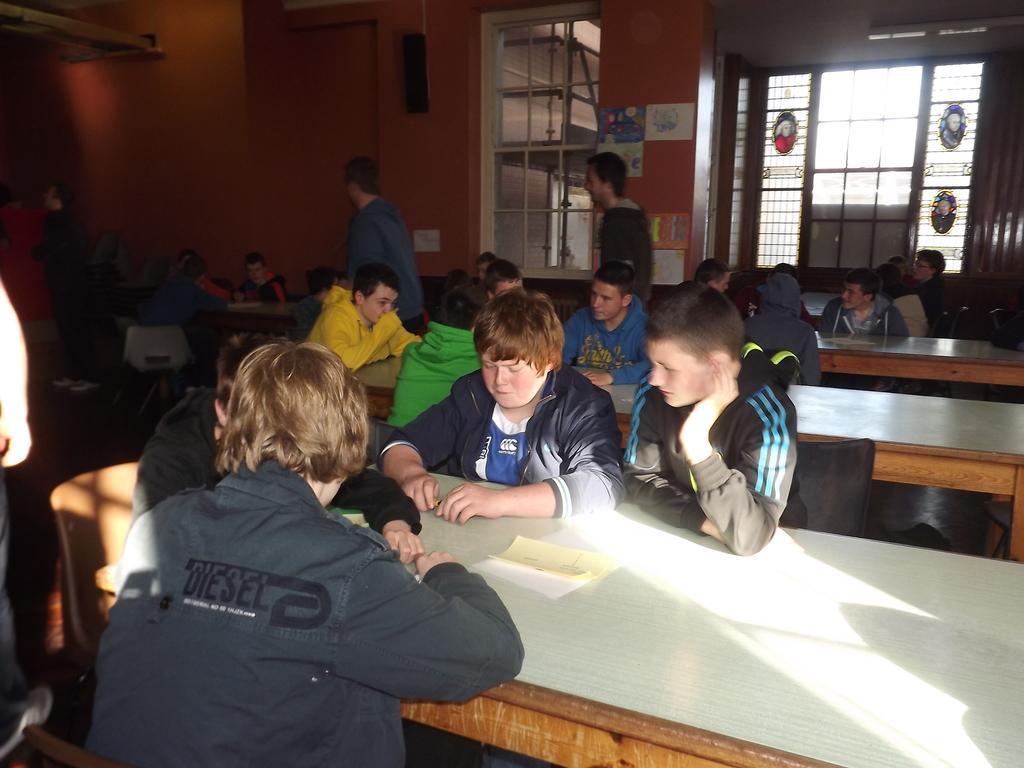Describe this image in one or two sentences. This is a picture taken in a room, there are a group of people sitting on chairs in front of these people there are tables on the table there are papers and some people are standing on the floor. Behind the people there are glass window, wall with poster and a speaker. 